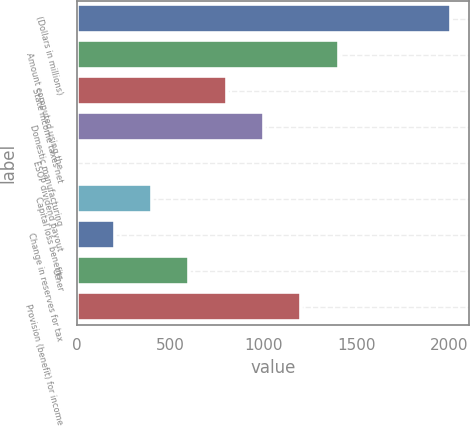<chart> <loc_0><loc_0><loc_500><loc_500><bar_chart><fcel>(Dollars in millions)<fcel>Amount computed using the<fcel>State income taxes net<fcel>Domestic manufacturing<fcel>ESOP dividend payout<fcel>Capital loss benefits<fcel>Change in reserves for tax<fcel>Other<fcel>Provision (benefit) for income<nl><fcel>2007<fcel>1405.2<fcel>803.4<fcel>1004<fcel>1<fcel>402.2<fcel>201.6<fcel>602.8<fcel>1204.6<nl></chart> 